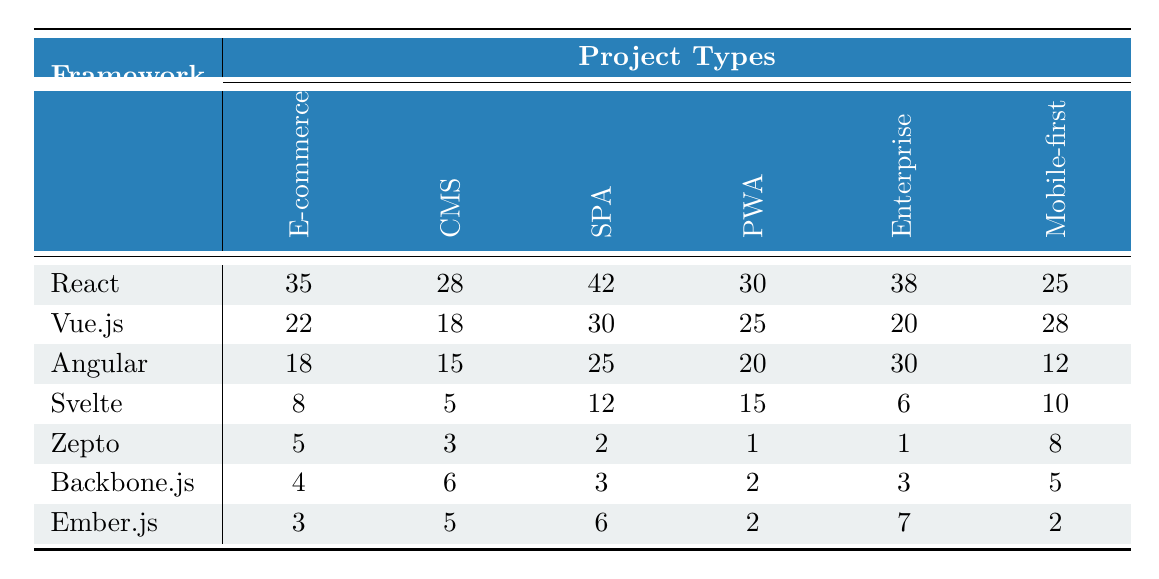What is the highest usage of React in a project type? Looking at the usage values for React across different project types, the highest value is 42, which corresponds to Single Page Applications.
Answer: 42 Which framework has the lowest usage in Progressive Web Apps? The values for Progressive Web Apps are: React (30), Vue.js (25), Angular (20), Svelte (15), Zepto (1), Backbone.js (2), and Ember.js (2). Therefore, Zepto has the lowest usage with a value of 1.
Answer: Zepto What are the total usage counts for Angular across all project types? Adding up the values for Angular: 18 (E-commerce) + 15 (CMS) + 25 (SPA) + 20 (PWA) + 30 (Enterprise) + 12 (Mobile-first) gives a total of 120.
Answer: 120 Is there any framework that is used equally in Mobile-first Websites and Content Management Systems? The usage for Mobile-first Websites and Content Management Systems respectively are: React (25, 28), Vue.js (28, 18), Angular (12, 15), Svelte (10, 5), Zepto (8, 3), Backbone.js (5, 6), and Ember.js (2, 5). There are no frameworks with equal usage in both categories.
Answer: No What is the difference in usage between the most and least used frameworks in E-commerce projects? The most used framework in E-commerce is React with 35, and the least used is Zepto with 5. The difference is 35 - 5 = 30.
Answer: 30 Which project type has the highest average usage across all frameworks? Calculating the average for each project type: E-commerce: (35+22+18+8+5+4+3)/7 = 13.57; CMS: (28+18+15+5+3+6+5)/7 = 12.14; SPA: (42+30+25+12+2+3+6)/7 = 15.14; PWA: (30+25+20+15+1+2+2)/7 = 11.14; Enterprise: (38+20+30+6+1+3+7)/7 = 12.14; Mobile-first: (25+28+12+10+8+5+2)/7 = 11.43. Therefore, Single Page Applications have the highest average usage of 15.14.
Answer: Single Page Application Which project type has the least total usage across all frameworks? Summing up the usages for each project type: E-commerce = 35 + 22 + 18 + 8 + 5 + 4 + 3 = 95; CMS = 28 + 18 + 15 + 5 + 3 + 6 + 5 = 80; SPA = 42 + 30 + 25 + 12 + 2 + 3 + 6 = 120; PWA = 30 + 25 + 20 + 15 + 1 + 2 + 2 = 95; Enterprise = 38 + 20 + 30 + 6 + 1 + 3 + 7 = 105; Mobile-first = 25 + 28 + 12 + 10 + 8 + 5 + 2 = 90. The least total usage is found in the Content Management Systems at 80.
Answer: Content Management System How many frameworks have a usage value greater than 20 in Single Page Applications? Looking at the SPA values, React (42), Vue.js (30), and Angular (25) all have values greater than 20, totaling three frameworks.
Answer: 3 Which framework has a higher total usage across all project types, Vue.js or Svelte? The total usage for Vue.js is 118 (22 + 18 + 30 + 25 + 20 + 28) and for Svelte is 56 (8 + 5 + 12 + 15 + 6 + 10). Since 118 is greater than 56, Vue.js has a higher total usage.
Answer: Vue.js Is the usage of Backbone.js higher for Mobile-first Websites or E-commerce? Backbone.js has usages of 5 in Mobile-first Websites and 4 in E-commerce. Since 5 is greater than 4, it has higher usage in Mobile-first Websites.
Answer: Mobile-first Websites 